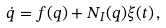Convert formula to latex. <formula><loc_0><loc_0><loc_500><loc_500>\dot { q } = { f } ( { q } ) + N _ { I } ( { q } ) { \xi } ( t ) \, ,</formula> 